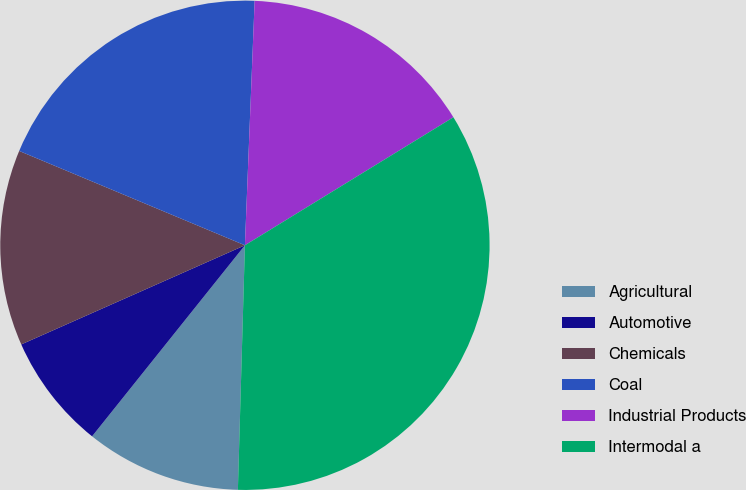<chart> <loc_0><loc_0><loc_500><loc_500><pie_chart><fcel>Agricultural<fcel>Automotive<fcel>Chemicals<fcel>Coal<fcel>Industrial Products<fcel>Intermodal a<nl><fcel>10.28%<fcel>7.62%<fcel>12.94%<fcel>19.33%<fcel>15.6%<fcel>34.22%<nl></chart> 